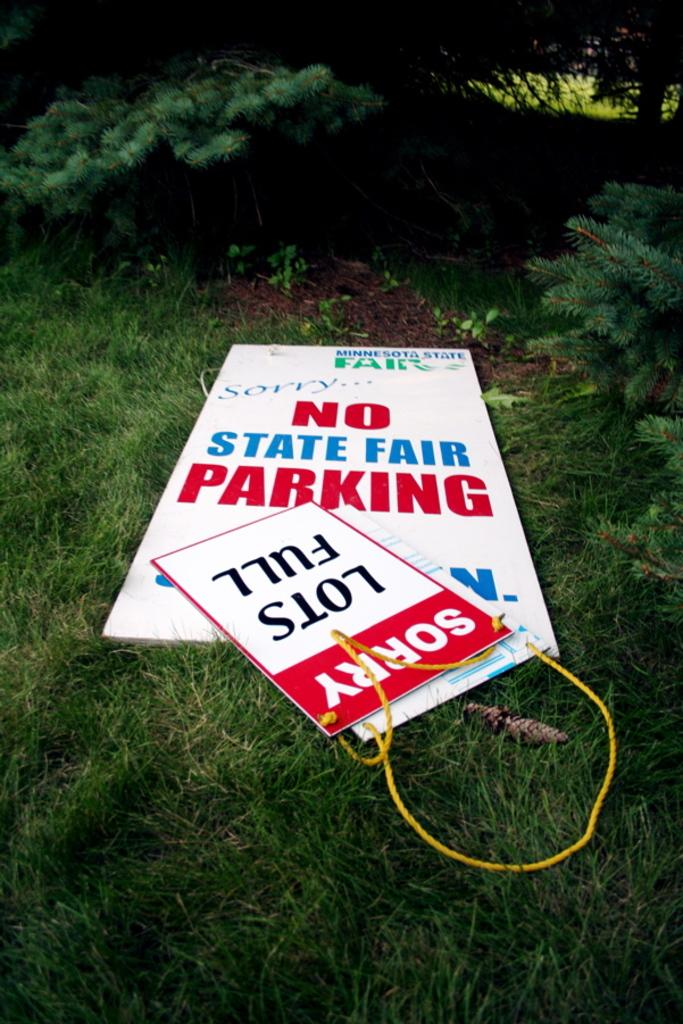What is located in the center of the image? There are boards in the center of the image. What type of vegetation is at the bottom of the image? There is grass at the bottom of the image. What can be seen in the background of the image? There are trees in the background of the image. How many legs can be seen supporting the boards in the image? There is no indication of legs supporting the boards in the image. What type of spoon is used to eat the grass in the image? There is no spoon present in the image, and grass is not typically eaten with a spoon. 